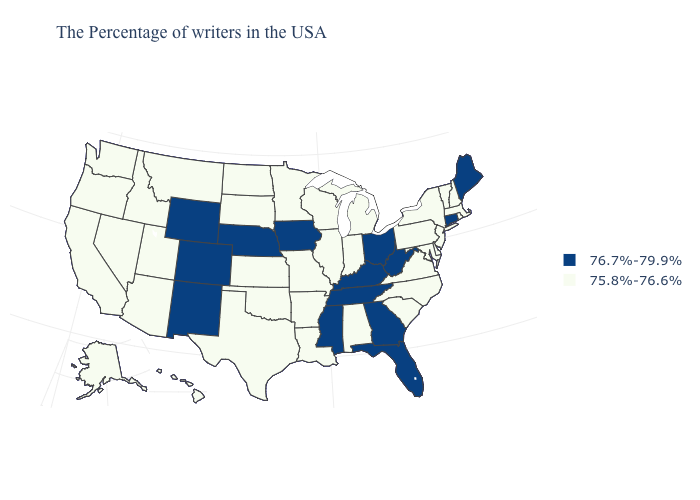Does Virginia have the lowest value in the South?
Concise answer only. Yes. Which states have the highest value in the USA?
Concise answer only. Maine, Connecticut, West Virginia, Ohio, Florida, Georgia, Kentucky, Tennessee, Mississippi, Iowa, Nebraska, Wyoming, Colorado, New Mexico. Does Tennessee have a higher value than Nebraska?
Quick response, please. No. Does Utah have the same value as Wisconsin?
Concise answer only. Yes. Which states have the highest value in the USA?
Write a very short answer. Maine, Connecticut, West Virginia, Ohio, Florida, Georgia, Kentucky, Tennessee, Mississippi, Iowa, Nebraska, Wyoming, Colorado, New Mexico. Name the states that have a value in the range 76.7%-79.9%?
Short answer required. Maine, Connecticut, West Virginia, Ohio, Florida, Georgia, Kentucky, Tennessee, Mississippi, Iowa, Nebraska, Wyoming, Colorado, New Mexico. What is the value of Kentucky?
Concise answer only. 76.7%-79.9%. Among the states that border Louisiana , which have the lowest value?
Short answer required. Arkansas, Texas. Name the states that have a value in the range 76.7%-79.9%?
Be succinct. Maine, Connecticut, West Virginia, Ohio, Florida, Georgia, Kentucky, Tennessee, Mississippi, Iowa, Nebraska, Wyoming, Colorado, New Mexico. What is the value of Illinois?
Answer briefly. 75.8%-76.6%. What is the lowest value in states that border West Virginia?
Short answer required. 75.8%-76.6%. Which states hav the highest value in the South?
Concise answer only. West Virginia, Florida, Georgia, Kentucky, Tennessee, Mississippi. Name the states that have a value in the range 75.8%-76.6%?
Write a very short answer. Massachusetts, Rhode Island, New Hampshire, Vermont, New York, New Jersey, Delaware, Maryland, Pennsylvania, Virginia, North Carolina, South Carolina, Michigan, Indiana, Alabama, Wisconsin, Illinois, Louisiana, Missouri, Arkansas, Minnesota, Kansas, Oklahoma, Texas, South Dakota, North Dakota, Utah, Montana, Arizona, Idaho, Nevada, California, Washington, Oregon, Alaska, Hawaii. Which states have the lowest value in the South?
Short answer required. Delaware, Maryland, Virginia, North Carolina, South Carolina, Alabama, Louisiana, Arkansas, Oklahoma, Texas. Which states hav the highest value in the Northeast?
Answer briefly. Maine, Connecticut. 